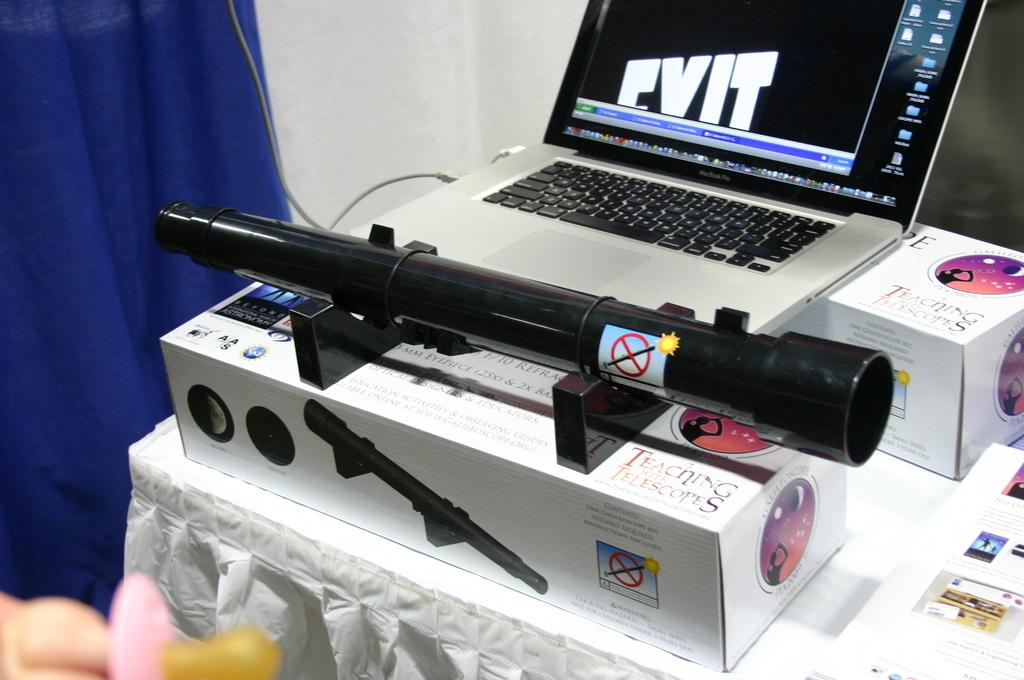<image>
Render a clear and concise summary of the photo. The telescope box is from the program teaching with telescopes 